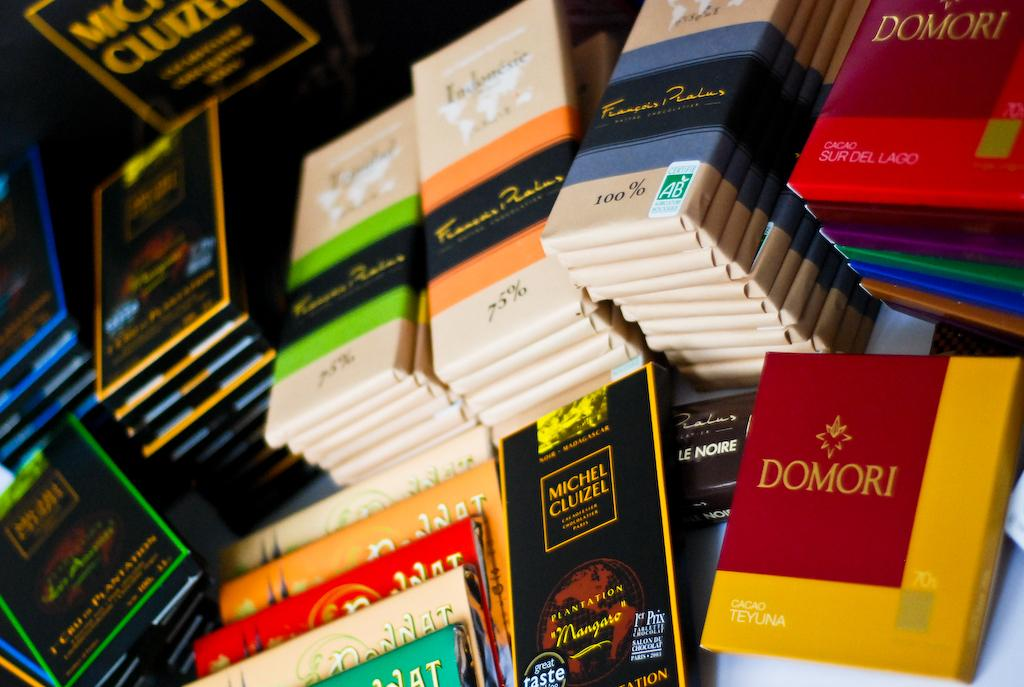<image>
Summarize the visual content of the image. A pile of books and one of them says Domori. 